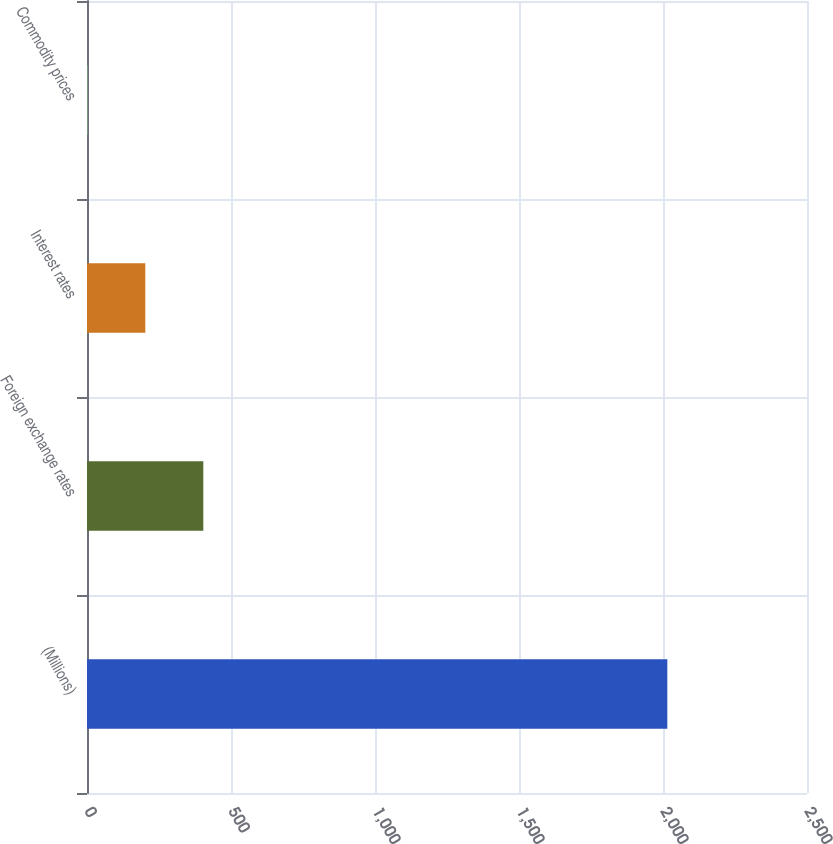<chart> <loc_0><loc_0><loc_500><loc_500><bar_chart><fcel>(Millions)<fcel>Foreign exchange rates<fcel>Interest rates<fcel>Commodity prices<nl><fcel>2015<fcel>403.8<fcel>202.4<fcel>1<nl></chart> 